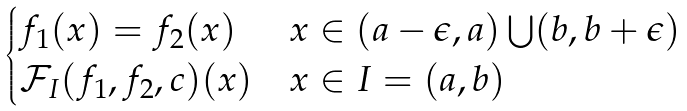Convert formula to latex. <formula><loc_0><loc_0><loc_500><loc_500>\begin{cases} f _ { 1 } ( x ) = f _ { 2 } ( x ) & x \in ( a - \epsilon , a ) \bigcup ( b , b + \epsilon ) \\ \mathcal { F } _ { I } ( f _ { 1 } , f _ { 2 } , c ) ( x ) & x \in I = ( a , b ) \\ \end{cases}</formula> 